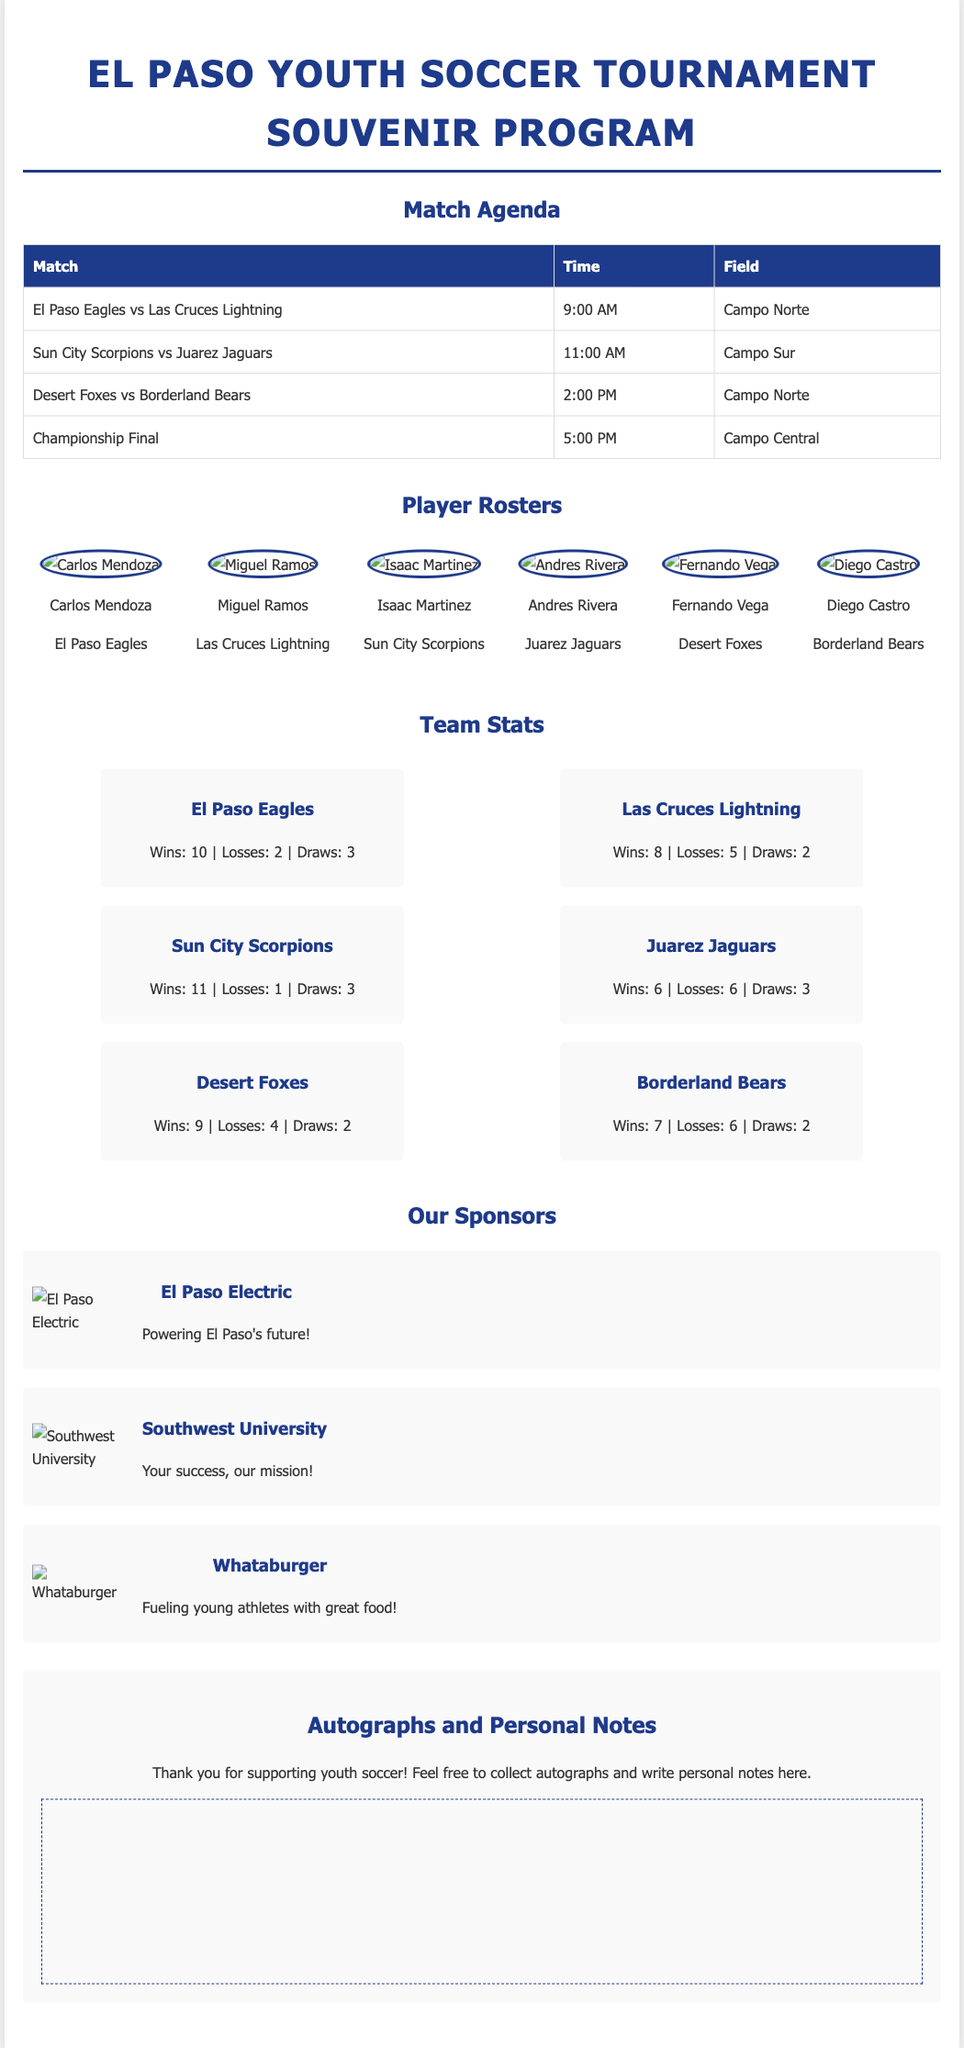What is the title of the document? The title is mentioned in the header section of the document.
Answer: El Paso Youth Soccer Tournament Souvenir Program How many teams are listed in the player rosters? The document provides information about the teams from the player rosters section.
Answer: 6 What time does the Championship Final start? The match agenda section specifies the time for each match, including the Championship Final.
Answer: 5:00 PM Which team has the most wins? The team stats section gives the win-loss records for each team, allowing for a comparison of wins.
Answer: Sun City Scorpions Who is one of the sponsors? The sponsors section lists various sponsors and their descriptions.
Answer: El Paso Electric What is the maximum width of the container in pixels? The document specifies the layout of the container, which includes the maximum width.
Answer: 1000px How many losses does the Las Cruces Lightning have? The team stats for Las Cruces Lightning detail their overall record.
Answer: 5 What is the purpose of the autographs section? The autographs section encourages engagement and personal memorabilia collection from the event.
Answer: Collect autographs and write personal notes Which field is El Paso Eagles playing on? The match agenda section indicates which field each match is played on, including the El Paso Eagles' match.
Answer: Campo Norte 